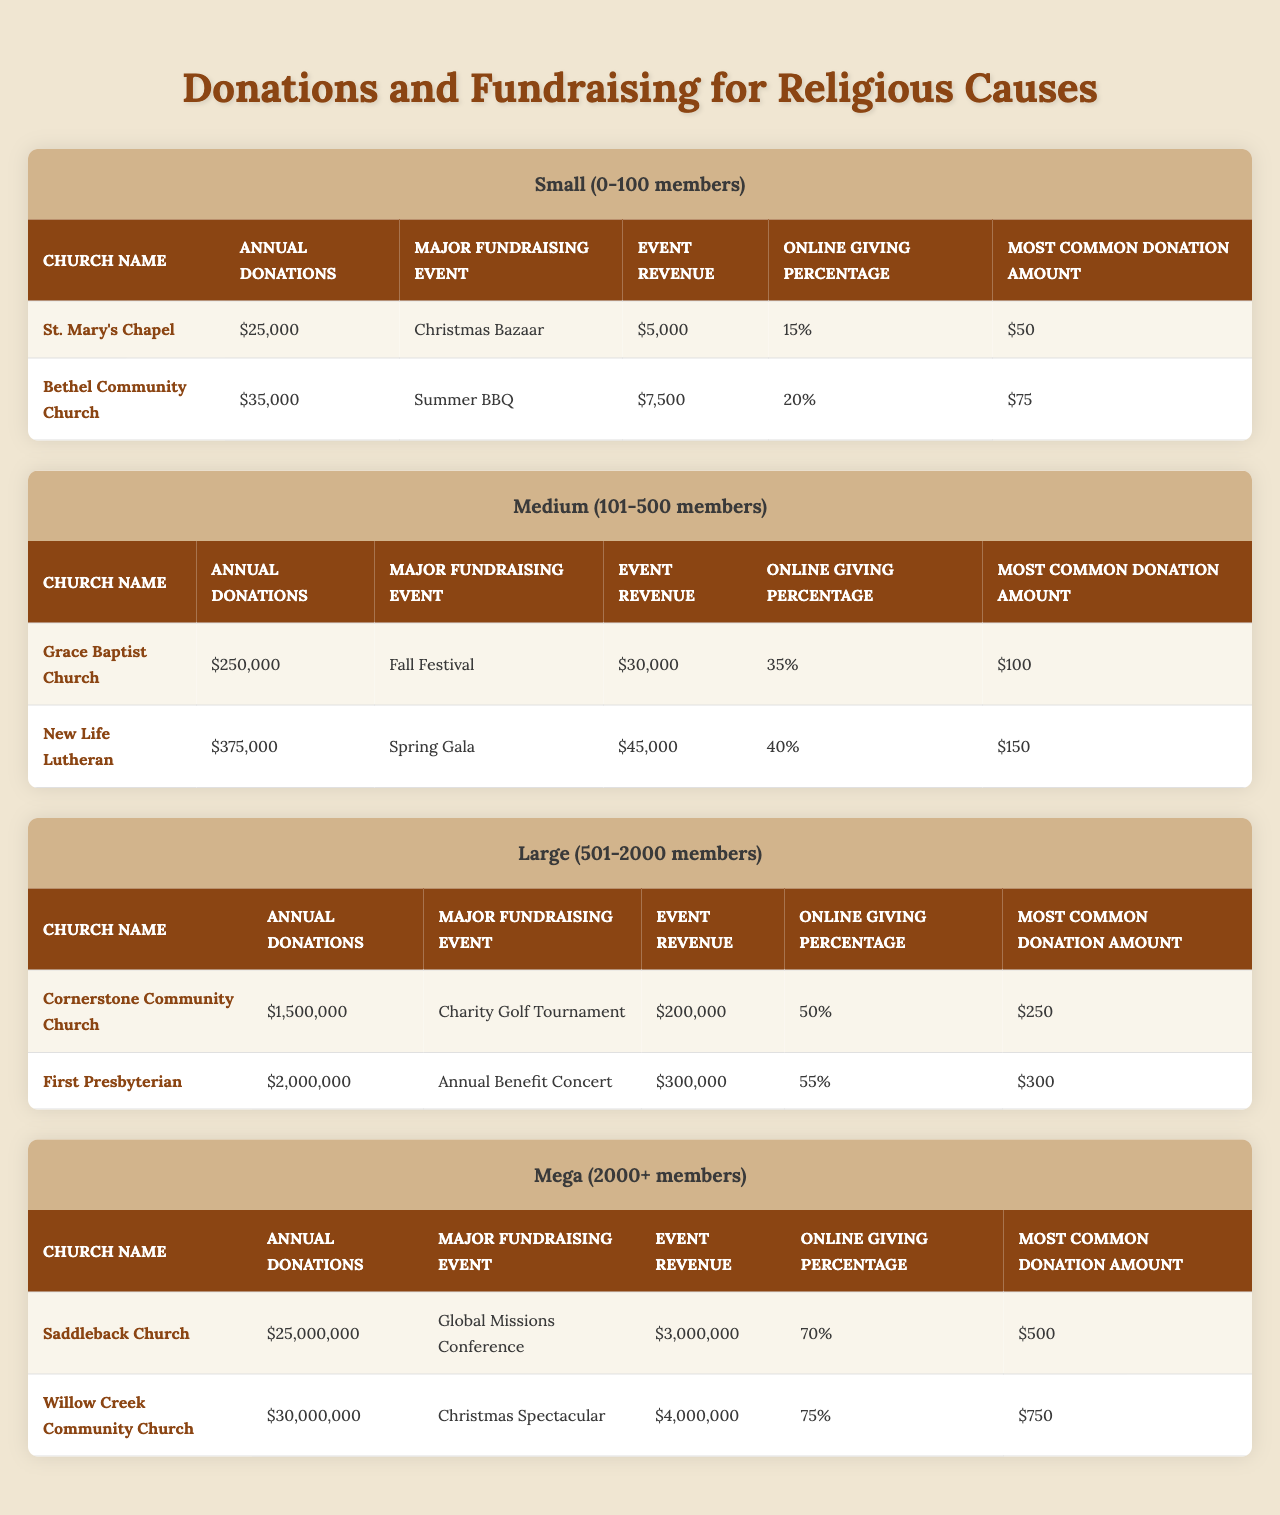What is the annual donation amount for Bethel Community Church? The table lists "Annual Donations" for Bethel Community Church as "$35,000".
Answer: $35,000 Which church had the highest annual donations in the Mega congregation size? According to the table, Saddleback Church had the highest annual donations of "$25,000,000" among Mega congregations.
Answer: Saddleback Church What is the major fundraising event for New Life Lutheran? The table indicates that the major fundraising event for New Life Lutheran is the "Spring Gala".
Answer: Spring Gala Calculate the total annual donations for all churches in the Small congregation size. The total annual donations for Small congregation size is calculated as $25,000 (St. Mary's Chapel) + $35,000 (Bethel Community Church) = $60,000.
Answer: $60,000 Is the online giving percentage for First Presbyterian Church greater than 50%? The table shows that the online giving percentage for First Presbyterian is "55%", which is greater than 50%.
Answer: Yes What is the most common donation amount for Cornerstone Community Church? The most common donation amount listed for Cornerstone Community Church in the table is "$250".
Answer: $250 Which congregation size has the highest average annual donation amount? To find the average: Small congregations total $60,000/2 = $30,000; Medium congregations total $625,000/2 = $312,500; Large congregations total $3,500,000/2 = $1,750,000; Mega congregations total $55,000,000/2 = $27,500,000. The Mega congregations have the highest average.
Answer: Mega What percentage of the total annual donations does Willow Creek Community Church represent among Mega congregations? Willow Creek Community Church has annual donations of $30,000,000 and total Mega donations of $55,000,000. Calculating the percentage: ($30,000,000 / $55,000,000) * 100 = 54.55%.
Answer: 54.55% How much more revenue did the First Presbyterian church generate from its major event compared to Grace Baptist Church? First Presbyterian generated $300,000 and Grace Baptist generated $30,000 from their major events. The difference is $300,000 - $30,000 = $270,000.
Answer: $270,000 Does St. Mary's Chapel receive more or less than 20% of its donations through online giving? St. Mary's Chapel has an online giving percentage of 15%, which is less than 20%.
Answer: Less What is the total event revenue for all churches in the Medium congregation size? For the Medium size: Grace Baptist Church = $30,000 + New Life Lutheran = $45,000, which totals $75,000 in event revenue.
Answer: $75,000 Which church has the highest online giving percentage? The table indicates that Willow Creek Community Church has the highest online giving percentage at "75%".
Answer: Willow Creek Community Church Calculate the average most common donation amount for the Large congregation size. For Large congregations: $250 (Cornerstone) + $300 (First Presbyterian) = $550; average = $550/2 = $275.
Answer: $275 Does the online giving percentage for churches in the Large congregation size exceed those in the Small size? Large congregation (Average: (50% + 55%)/2 = 52.5%) exceeds Small congregation (Average: (15% + 20%)/2 = 17.5%) in online giving percentage.
Answer: Yes 